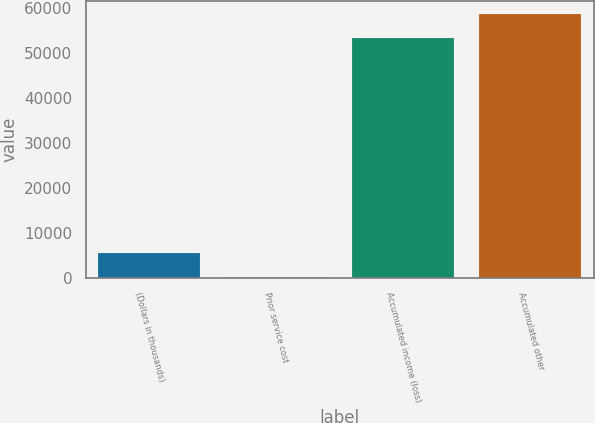<chart> <loc_0><loc_0><loc_500><loc_500><bar_chart><fcel>(Dollars in thousands)<fcel>Prior service cost<fcel>Accumulated income (loss)<fcel>Accumulated other<nl><fcel>5401.7<fcel>70<fcel>53318<fcel>58649.7<nl></chart> 